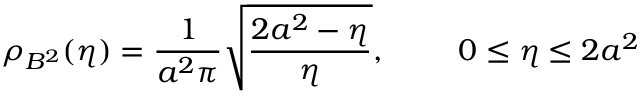Convert formula to latex. <formula><loc_0><loc_0><loc_500><loc_500>\rho _ { B ^ { 2 } } ( \eta ) = \frac { 1 } { a ^ { 2 } \pi } \sqrt { \frac { 2 a ^ { 2 } - \eta } { \eta } } , \quad 0 \leq \eta \leq 2 a ^ { 2 }</formula> 